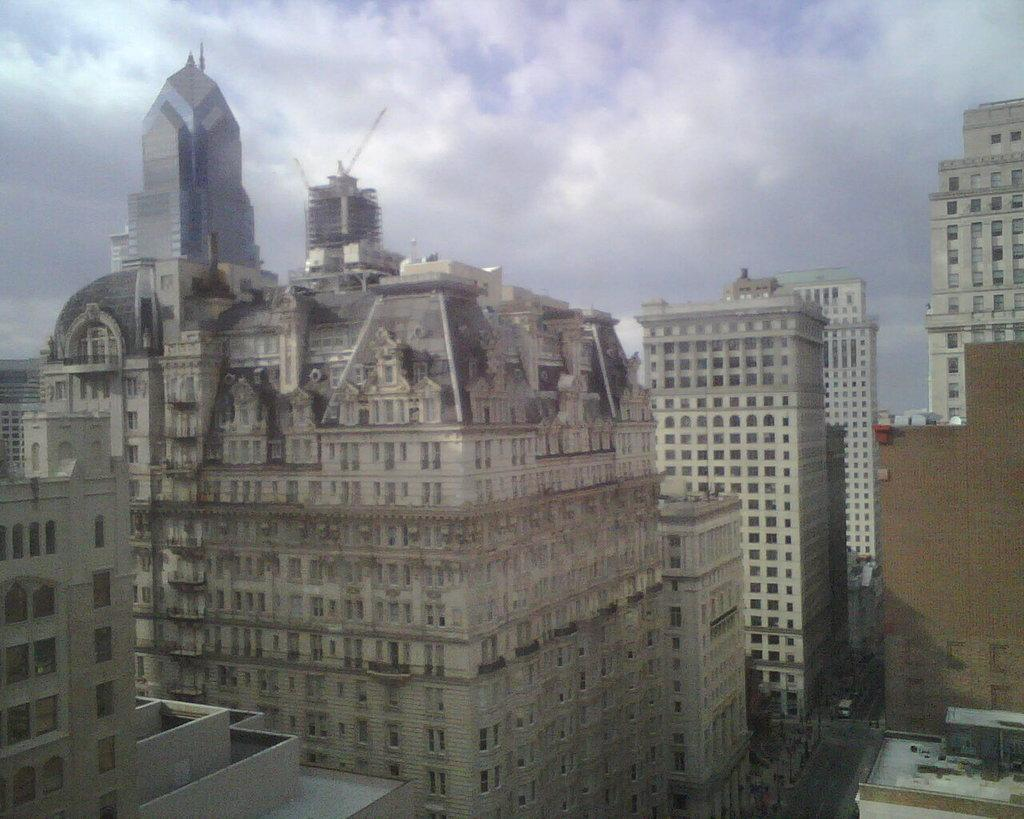What type of structures can be seen in the image? There are buildings in the image. What else can be seen on the ground in the image? There are vehicles on the road in the image. What are the tall, thin objects in the image? There are poles in the image. What is visible in the sky in the image? There are clouds in the sky in the image. Where is the locket hanging in the image? There is no locket present in the image. What type of cream is being used by the vehicles in the image? There is no cream being used by the vehicles in the image; they are not shown in motion or interacting with any substance. 